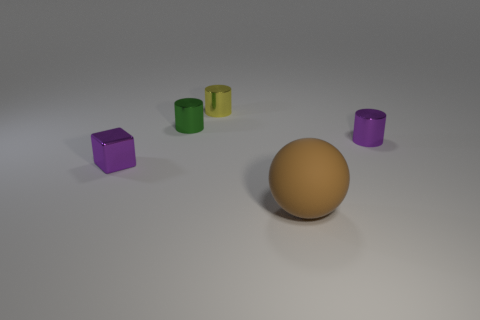Add 1 purple blocks. How many objects exist? 6 Subtract all cubes. How many objects are left? 4 Subtract all tiny green matte things. Subtract all brown rubber balls. How many objects are left? 4 Add 4 purple metal blocks. How many purple metal blocks are left? 5 Add 5 blue shiny blocks. How many blue shiny blocks exist? 5 Subtract 1 brown balls. How many objects are left? 4 